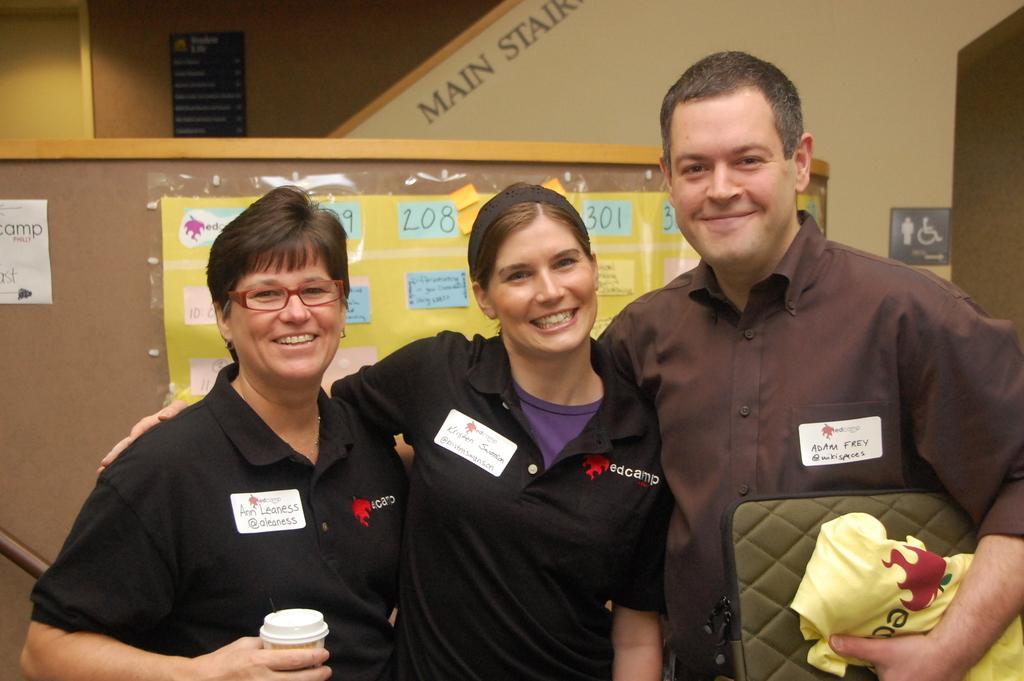Could you give a brief overview of what you see in this image? On the background of the picture we can see a wall in brown colour. This is a blackboard. Here we can see stairs and it is written on the wall stating main stairs. This is a sign board. In Front of the picture we can see three persons standing carrying a pretty smile on their faces. On the right side of the picture there is a man holding a bag and a cover in his hand. On the left side of the picture there is a woman holding a glass in her hand. At the backside of them we can see a board with a yellow chart and some stickers pasted on it. 